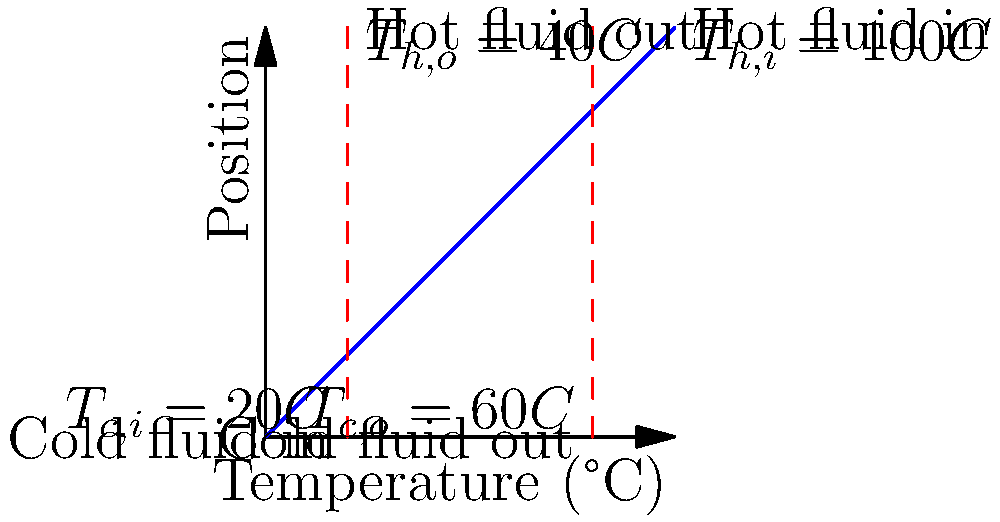A counter-flow heat exchanger is used in an e-commerce platform's server cooling system. The hot fluid (server coolant) enters at 100°C and exits at 40°C, while the cold fluid (ambient air) enters at 20°C and exits at 60°C. Calculate the effectiveness of this heat exchanger. To calculate the effectiveness of the heat exchanger, we'll follow these steps:

1. Determine the maximum possible heat transfer:
   The maximum heat transfer occurs when the hot fluid is cooled to the inlet temperature of the cold fluid.
   $$\Delta T_{max} = T_{h,i} - T_{c,i} = 100°C - 20°C = 80°C$$

2. Calculate the actual heat transfer:
   We can use either the hot or cold fluid for this calculation. Let's use the hot fluid.
   $$\Delta T_{actual} = T_{h,i} - T_{h,o} = 100°C - 40°C = 60°C$$

3. Calculate the effectiveness (ε):
   Effectiveness is the ratio of actual heat transfer to maximum possible heat transfer.
   $$\varepsilon = \frac{\Delta T_{actual}}{\Delta T_{max}} = \frac{60°C}{80°C} = 0.75$$

4. Convert to percentage:
   $$\varepsilon = 0.75 \times 100\% = 75\%$$

Therefore, the effectiveness of this heat exchanger is 75%.
Answer: 75% 